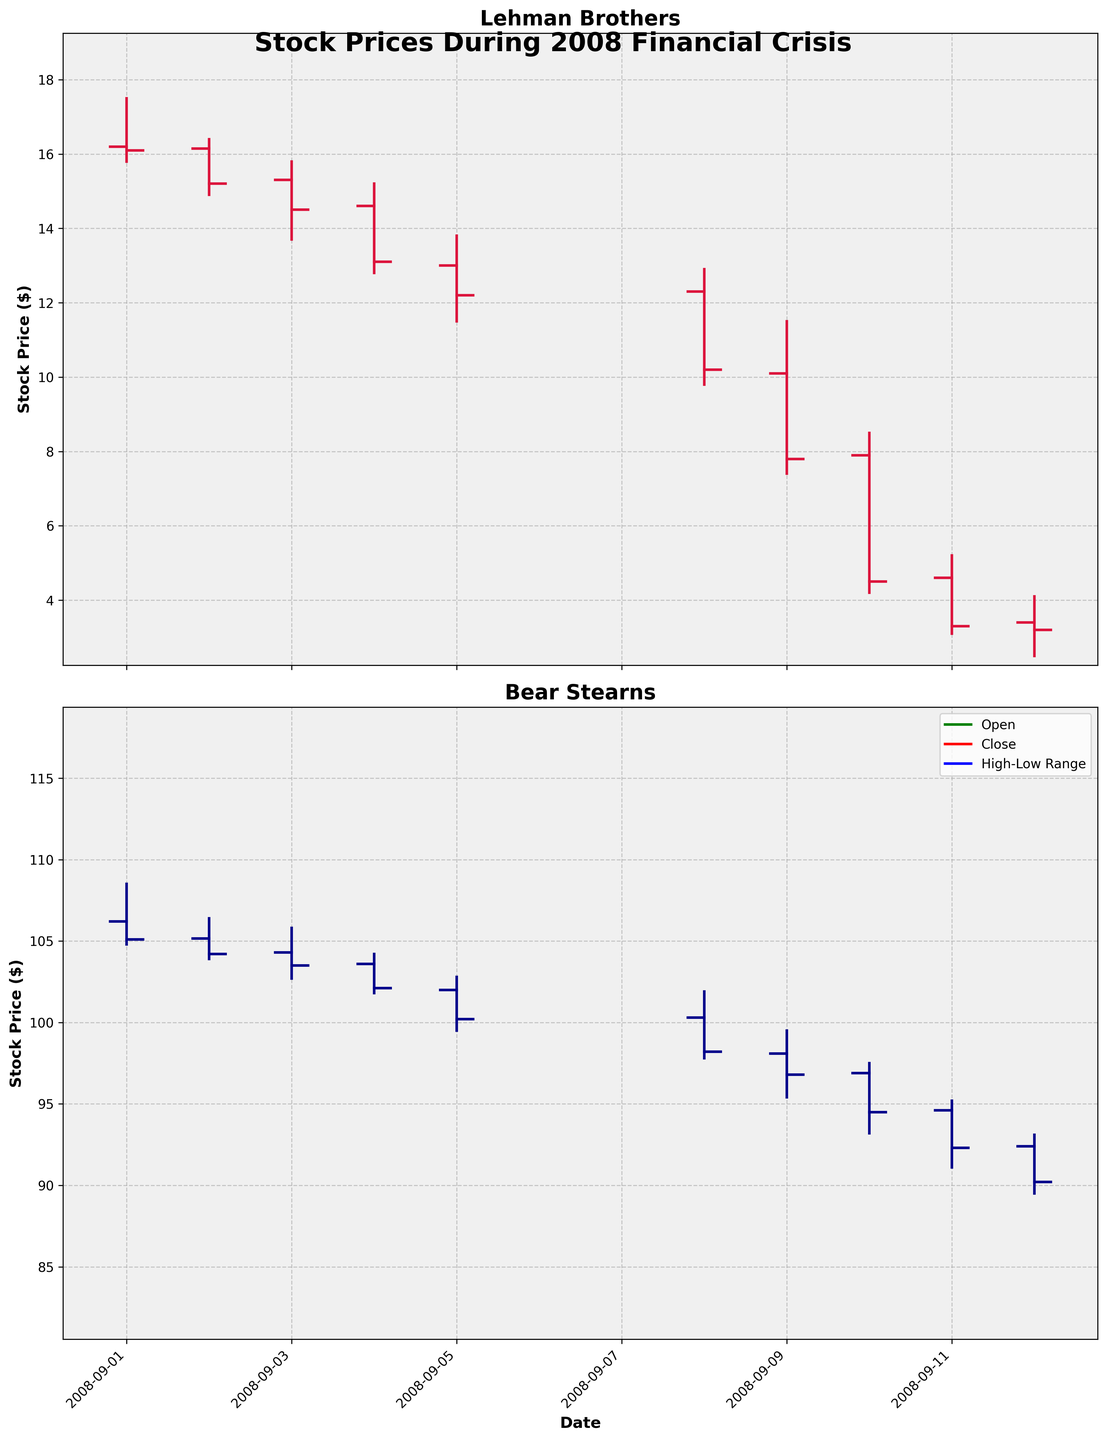what is the highest closing price for Lehman Brothers in the given period? Identify the highest closing value in the Lehman Brothers data. The highest value in the provided closing prices: 16.10, 15.20, 14.50, 13.10, 12.20, 10.20, 7.80, 4.50, 3.30, 3.20 is 16.10.
Answer: 16.10 what is the trend in Bear Stearns' stock price from September 1 to September 12, 2008? Look at the closing prices for Bear Stearns from September 1 to September 12, 2008. Notice a steady decline from 105.10 down to 90.20. This indicates a downward trend.
Answer: Downward trend what date did Lehman Brothers experience the highest price fluctuation (difference between high and low)? Calculate the difference between high and low for each date for Lehman Brothers and identify the date with the biggest difference. The largest fluctuation occurs on 2008-09-09 (11.50 - 7.40 = 4.10).
Answer: 2008-09-09 which bank had a higher stock price on September 05, 2008? Compare the closing prices for both Lehman Brothers (12.20) and Bear Stearns (100.20) on September 05, 2008. Bear Stearns had a significantly higher stock price.
Answer: Bear Stearns on which date did Lehman Brothers' stock price drop below $10 for the first time? Examine the closing prices for Lehman Brothers until finding the first instance they drop below $10. This occurs on 2008-09-09 when the closing price is 7.80.
Answer: 2008-09-09 what was the percentage decrease in closing stock price for Lehman Brothers from September 1, 2008, to September 12, 2008? Calculate the percentage decrease: ((initial price - final price) / initial price) * 100. For Lehman Brothers: ((16.10 - 3.20) / 16.10) * 100 = 80.12%.
Answer: 80.12% which bank showed more stability (less fluctuation) in their stock prices during the period? Compare the ranges (differences between high and low) for both banks. Lehman Brothers had large fluctuations, e.g., on 2008-09-09 (4.10), while Bear Stearns had smaller ranges. Bear Stearns exhibited more stability.
Answer: Bear Stearns how did Bear Stearns' stock price change from September 8 to September 12, 2008? Look at the closing prices from September 8 (98.20) to September 12 (90.20). Calculate the difference: 98.20 - 90.20 = 8. The stock price decreased by 8.
Answer: Decreased by 8 